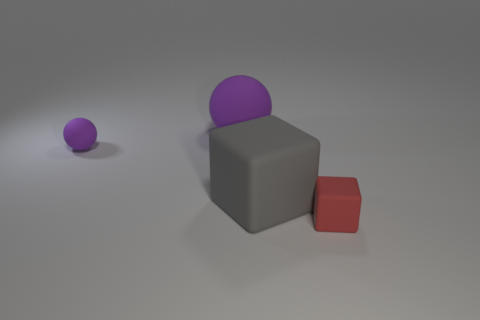What size is the rubber object that is the same color as the large sphere? The rubber object that shares the large sphere's purple color is small in size compared to the gray cube and the large sphere. 